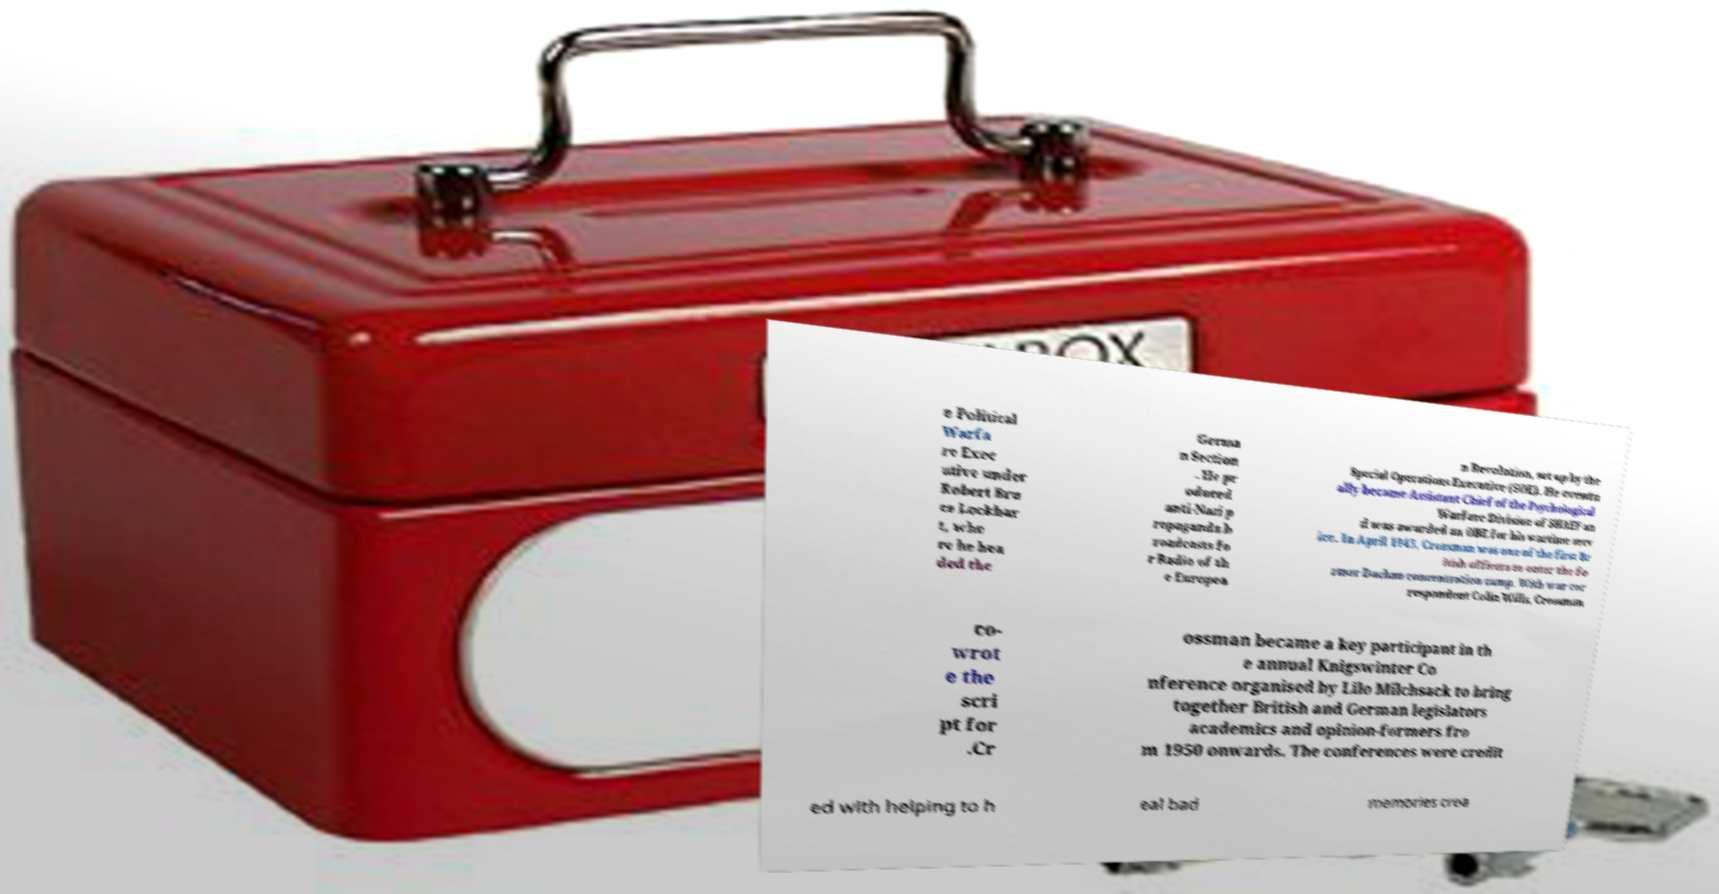Could you assist in decoding the text presented in this image and type it out clearly? e Political Warfa re Exec utive under Robert Bru ce Lockhar t, whe re he hea ded the Germa n Section . He pr oduced anti-Nazi p ropaganda b roadcasts fo r Radio of th e Europea n Revolution, set up by the Special Operations Executive (SOE). He eventu ally became Assistant Chief of the Psychological Warfare Division of SHAEF an d was awarded an OBE for his wartime serv ice. In April 1945, Crossman was one of the first Br itish officers to enter the fo rmer Dachau concentration camp. With war cor respondent Colin Wills, Crossman co- wrot e the scri pt for .Cr ossman became a key participant in th e annual Knigswinter Co nference organised by Lilo Milchsack to bring together British and German legislators academics and opinion-formers fro m 1950 onwards. The conferences were credit ed with helping to h eal bad memories crea 